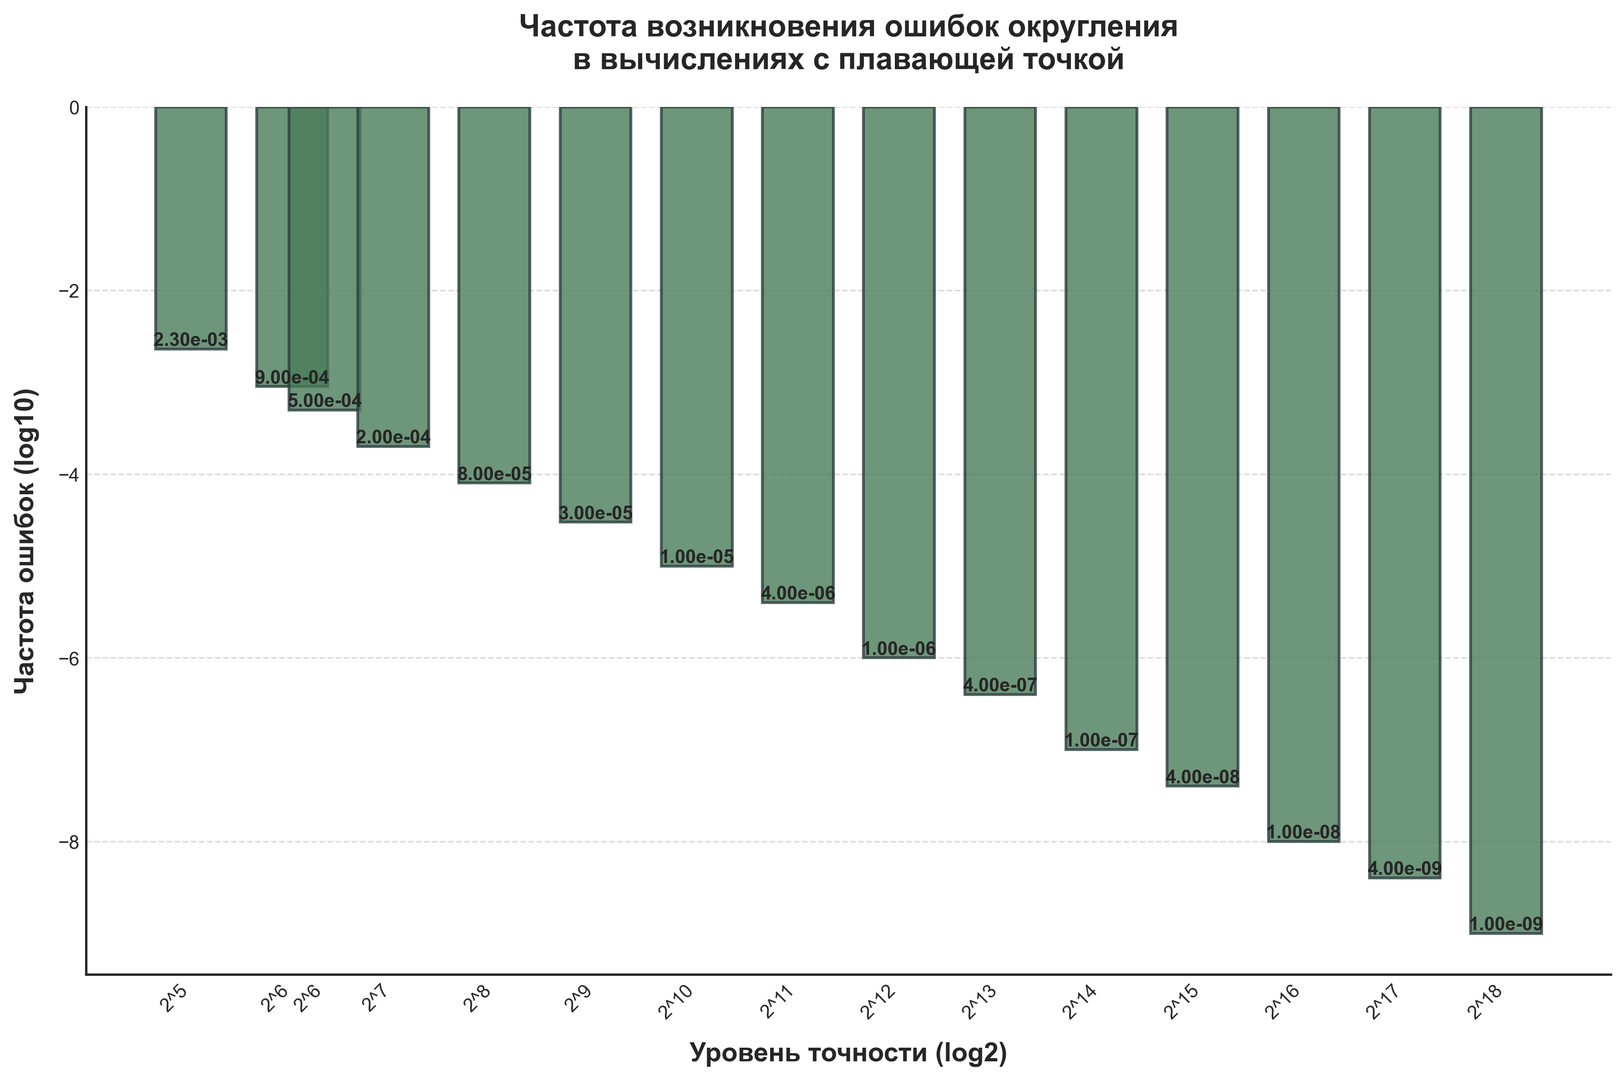What's the precision level at which the frequency of errors is 0.0001? To find the precision level where the error frequency is 0.0001, locate the bar with the corresponding y-value (error frequency in log10). The error frequency of 0.0001 corresponds to an entry at 16384 precision level.
Answer: 16384 At what precision level do errors occur less frequently than 10^-5? First, determine the log10 value of 10^-5, which is -5. Then, find the bars with y-values lower (more negative) than -5. The precision levels with error frequencies less than 10^-5 are those with values from 65536 and higher.
Answer: 65536 and higher How does the error frequency change as the precision level doubles? Notice that the error frequency decreases logarithmically with an increase in precision levels. This relationship indicates a non-linear reduction. Specifically, doubling the precision level results in an error frequency reduction that is less than proportional due to the logarithmic scale.
Answer: Error frequency decreases non-linearly Which precision level has an error frequency of approximately 3.3e-3? Find the bar that corresponds to the log10 value of 3.3e-3, which is close to -2.5. The approximate precision level for this frequency is 32.
Answer: 32 Compare the error frequency between precision levels of 128 and 1024. First, locate the bars corresponding to 128 and 1024 precision levels. The y-values (in log10) for these are -3.7 and -5 respectively, indicating that the error frequency at 1024 is lower than at 128. This confirms that as precision increases, error frequency decreases considerably.
Answer: 1024 has lower error frequency What is the average log10 error frequency for precision levels 256, 512, and 1024? To calculate the average, first get the log10 error frequencies: -4.1 (256), -4.5 (512), and -5 (1024). Sum these values: -4.1 + (-4.5) + (-5) = -13.6. Then divide by 3 for the average: -13.6 / 3 ≈ -4.53.
Answer: -4.53 Describe the color and placement of the bars in the graph. The bars in the graph are colored green with a slight transparency (opacity). The bars are aligned vertically along the x-axis, which is logarithmically scaled, and are evenly spaced representing different precision levels. The heights (y-values) of the bars represent the logarithm of error frequency in base 10.
Answer: Green, vertically aligned, log-scaled How many precision levels have an error frequency less than 10^-7? To find this, locate the bars where the error frequency (y-value) is below -7 on the log10 scale. These levels are from 32768 onwards. Counting these precision levels gives a total of 7 levels.
Answer: 7 What is the log2 value at which the first visually significant decrease in error frequency occurs? Identify the first steep drop in the bar heights representing the significant decrease. This can be observed visually around precision level 128, where the bar height reduces noticeably compared to its neighbors. Log2(128) equals 7.
Answer: 7 